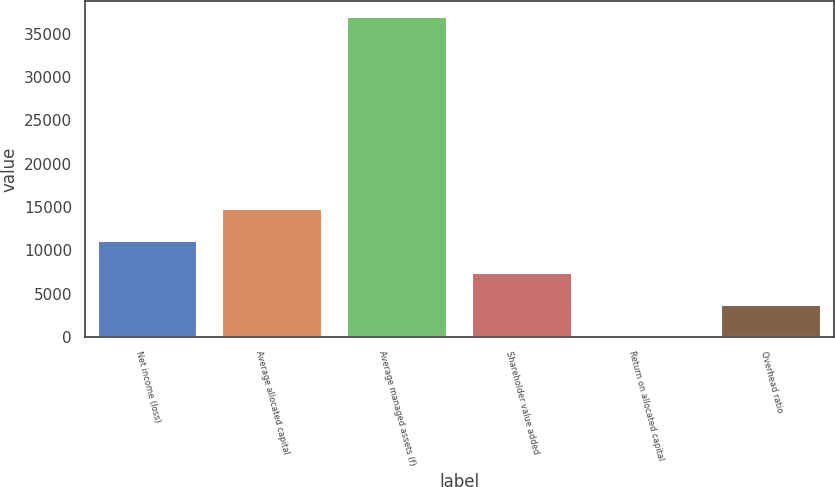<chart> <loc_0><loc_0><loc_500><loc_500><bar_chart><fcel>Net income (loss)<fcel>Average allocated capital<fcel>Average managed assets (f)<fcel>Shareholder value added<fcel>Return on allocated capital<fcel>Overhead ratio<nl><fcel>11073<fcel>14762<fcel>36896<fcel>7384<fcel>6<fcel>3695<nl></chart> 